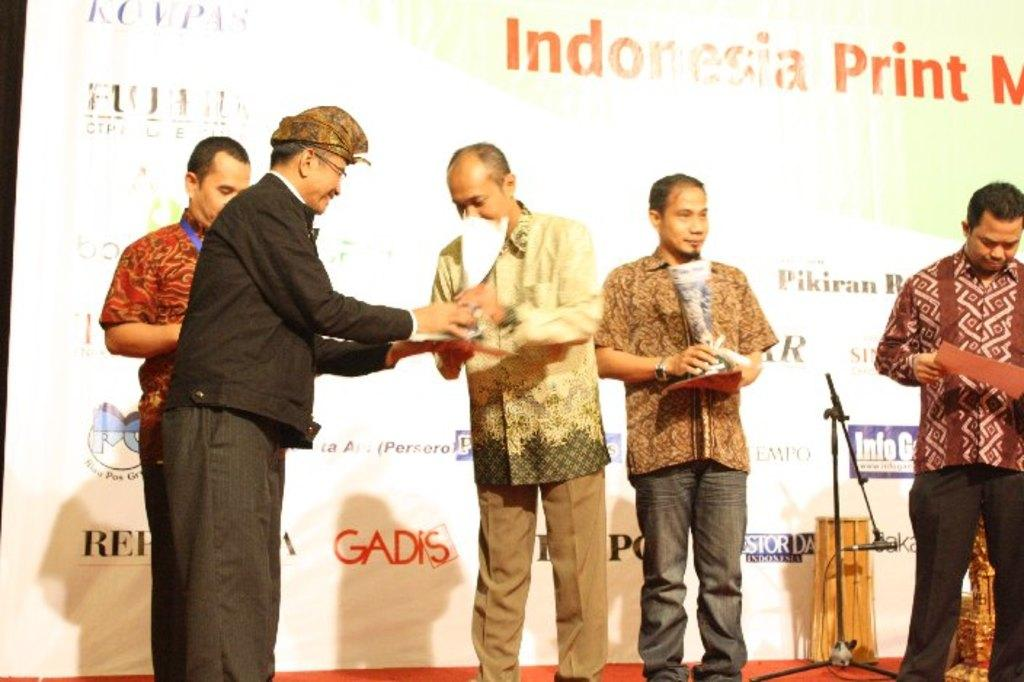What is happening on the stage in the image? There are people standing on the stage in the image. What are the people holding? The people are holding objects in the image. Can you describe any equipment on the stage? Yes, there is a mic stand in the image. What can be seen in the background of the stage? There is a banner with text in the background. What color is the dress worn by the person in the image? There is no person wearing a dress in the image; the people on the stage are not wearing dresses. 